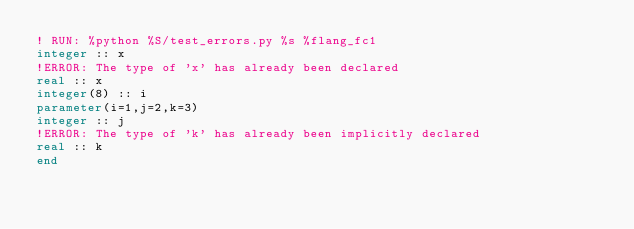Convert code to text. <code><loc_0><loc_0><loc_500><loc_500><_FORTRAN_>! RUN: %python %S/test_errors.py %s %flang_fc1
integer :: x
!ERROR: The type of 'x' has already been declared
real :: x
integer(8) :: i
parameter(i=1,j=2,k=3)
integer :: j
!ERROR: The type of 'k' has already been implicitly declared
real :: k
end
</code> 